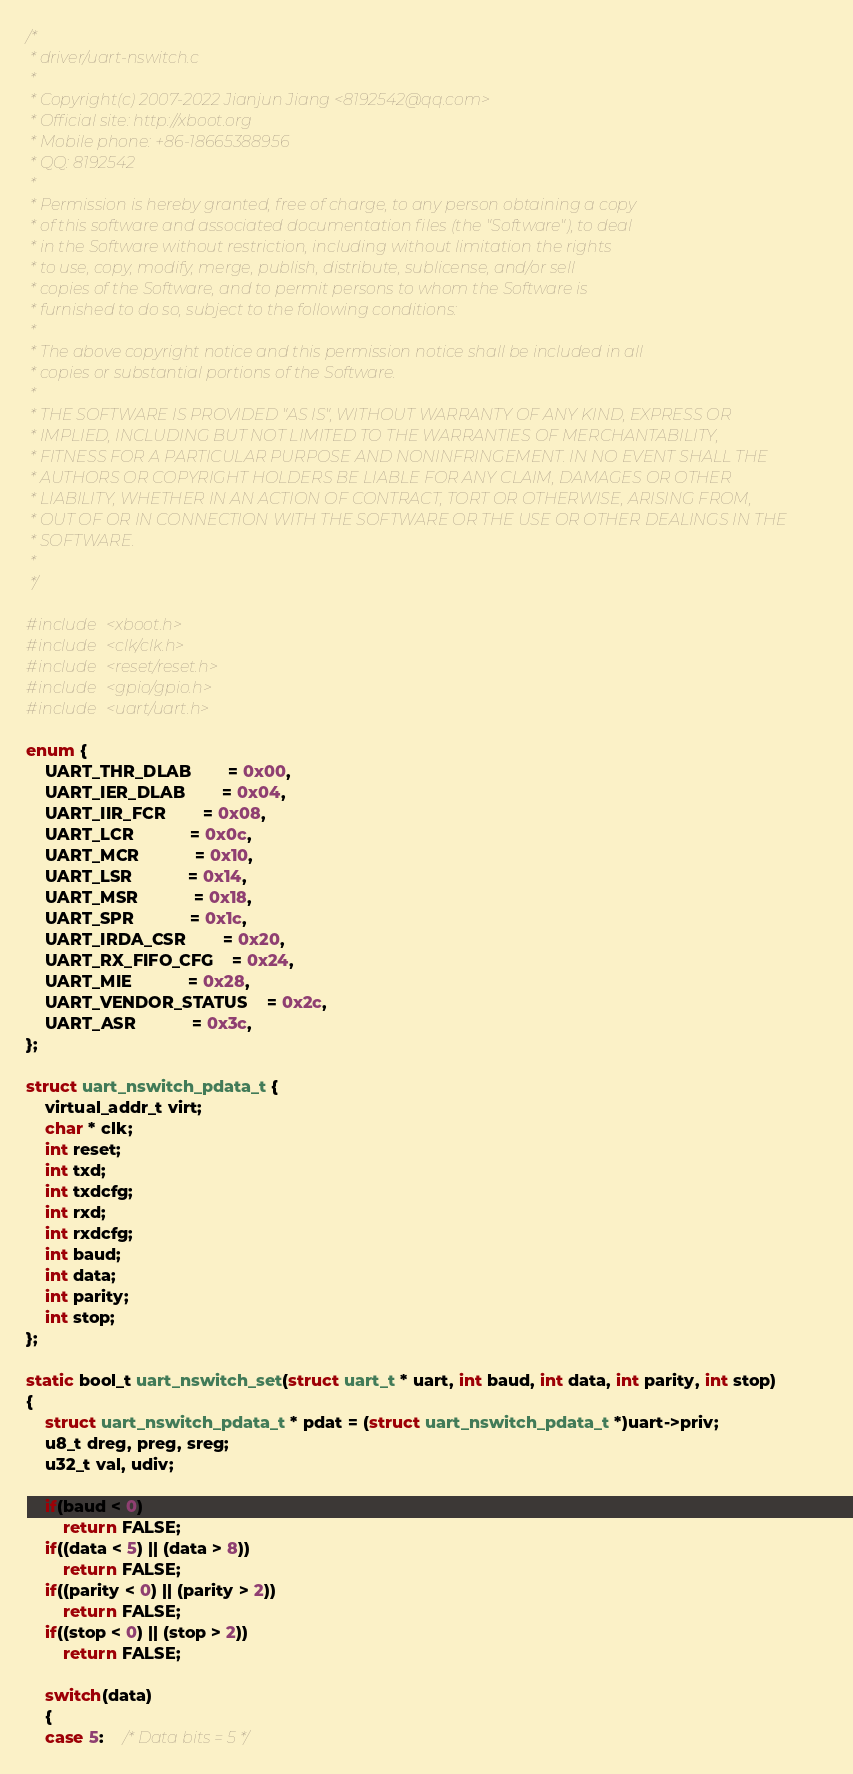<code> <loc_0><loc_0><loc_500><loc_500><_C_>/*
 * driver/uart-nswitch.c
 *
 * Copyright(c) 2007-2022 Jianjun Jiang <8192542@qq.com>
 * Official site: http://xboot.org
 * Mobile phone: +86-18665388956
 * QQ: 8192542
 *
 * Permission is hereby granted, free of charge, to any person obtaining a copy
 * of this software and associated documentation files (the "Software"), to deal
 * in the Software without restriction, including without limitation the rights
 * to use, copy, modify, merge, publish, distribute, sublicense, and/or sell
 * copies of the Software, and to permit persons to whom the Software is
 * furnished to do so, subject to the following conditions:
 *
 * The above copyright notice and this permission notice shall be included in all
 * copies or substantial portions of the Software.
 *
 * THE SOFTWARE IS PROVIDED "AS IS", WITHOUT WARRANTY OF ANY KIND, EXPRESS OR
 * IMPLIED, INCLUDING BUT NOT LIMITED TO THE WARRANTIES OF MERCHANTABILITY,
 * FITNESS FOR A PARTICULAR PURPOSE AND NONINFRINGEMENT. IN NO EVENT SHALL THE
 * AUTHORS OR COPYRIGHT HOLDERS BE LIABLE FOR ANY CLAIM, DAMAGES OR OTHER
 * LIABILITY, WHETHER IN AN ACTION OF CONTRACT, TORT OR OTHERWISE, ARISING FROM,
 * OUT OF OR IN CONNECTION WITH THE SOFTWARE OR THE USE OR OTHER DEALINGS IN THE
 * SOFTWARE.
 *
 */

#include <xboot.h>
#include <clk/clk.h>
#include <reset/reset.h>
#include <gpio/gpio.h>
#include <uart/uart.h>

enum {
	UART_THR_DLAB		= 0x00,
	UART_IER_DLAB		= 0x04,
	UART_IIR_FCR		= 0x08,
	UART_LCR			= 0x0c,
	UART_MCR			= 0x10,
	UART_LSR			= 0x14,
	UART_MSR			= 0x18,
	UART_SPR			= 0x1c,
	UART_IRDA_CSR		= 0x20,
	UART_RX_FIFO_CFG	= 0x24,
	UART_MIE			= 0x28,
	UART_VENDOR_STATUS	= 0x2c,
	UART_ASR			= 0x3c,
};

struct uart_nswitch_pdata_t {
	virtual_addr_t virt;
	char * clk;
	int reset;
	int txd;
	int txdcfg;
	int rxd;
	int rxdcfg;
	int baud;
	int data;
	int parity;
	int stop;
};

static bool_t uart_nswitch_set(struct uart_t * uart, int baud, int data, int parity, int stop)
{
	struct uart_nswitch_pdata_t * pdat = (struct uart_nswitch_pdata_t *)uart->priv;
	u8_t dreg, preg, sreg;
	u32_t val, udiv;

	if(baud < 0)
		return FALSE;
	if((data < 5) || (data > 8))
		return FALSE;
	if((parity < 0) || (parity > 2))
		return FALSE;
	if((stop < 0) || (stop > 2))
		return FALSE;

	switch(data)
	{
	case 5:	/* Data bits = 5 */</code> 